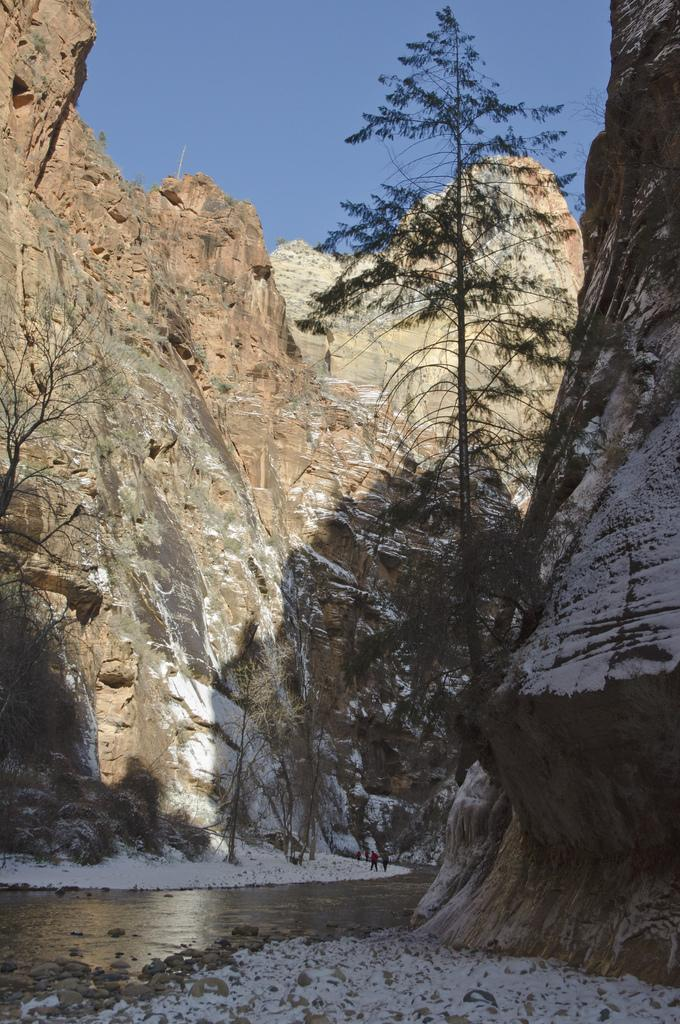What is present in the image that represents a natural resource? There is water in the image. How many people can be seen in the image? There are two persons in the image. What type of weather condition is depicted in the image? There is snow in the image. What type of terrain can be seen in the image? There are stones, trees, and hills in the image. What is visible in the background of the image? The sky is visible in the background of the image. What type of coach can be seen in the image? There is no coach present in the image. What type of building can be seen in the image? There is no building present in the image. 